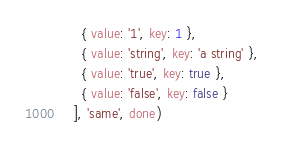<code> <loc_0><loc_0><loc_500><loc_500><_JavaScript_>      { value: '1', key: 1 },
      { value: 'string', key: 'a string' },
      { value: 'true', key: true },
      { value: 'false', key: false }
    ], 'same', done)</code> 